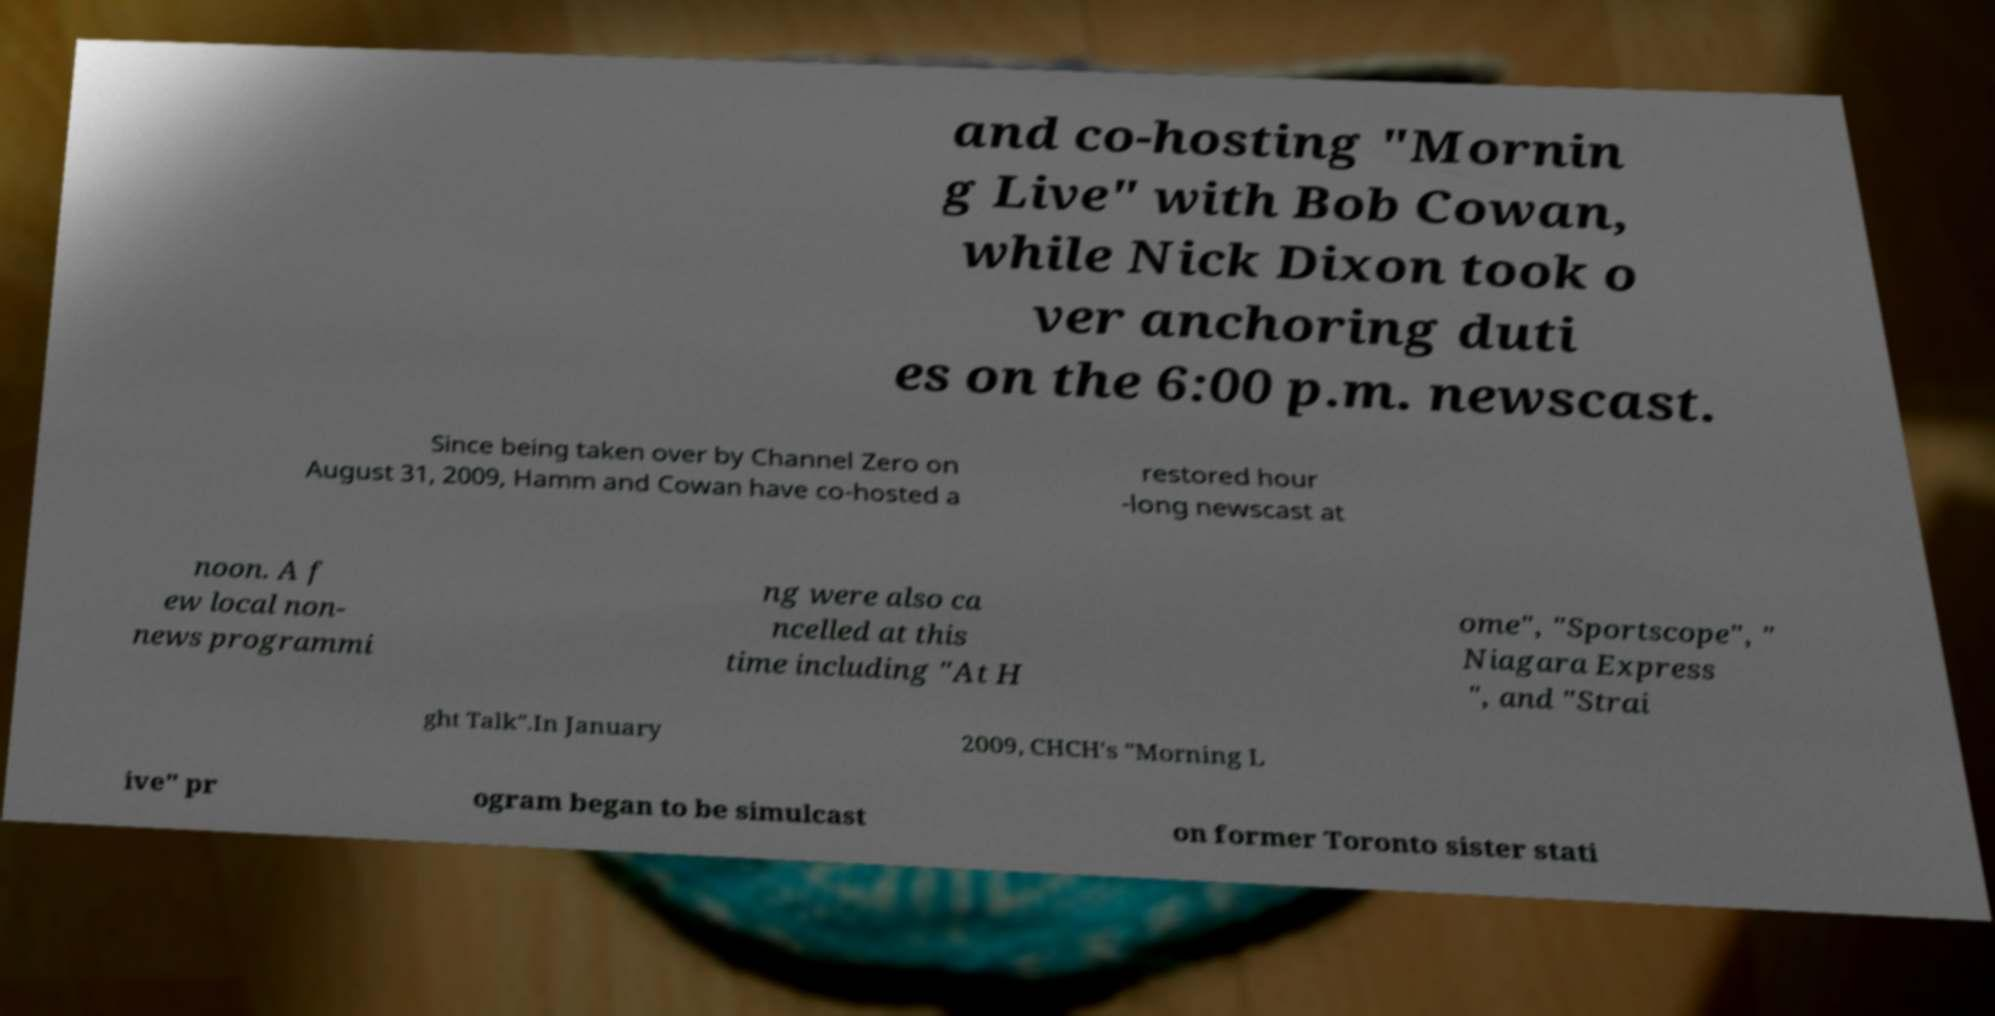Could you assist in decoding the text presented in this image and type it out clearly? and co-hosting "Mornin g Live" with Bob Cowan, while Nick Dixon took o ver anchoring duti es on the 6:00 p.m. newscast. Since being taken over by Channel Zero on August 31, 2009, Hamm and Cowan have co-hosted a restored hour -long newscast at noon. A f ew local non- news programmi ng were also ca ncelled at this time including "At H ome", "Sportscope", " Niagara Express ", and "Strai ght Talk".In January 2009, CHCH's "Morning L ive" pr ogram began to be simulcast on former Toronto sister stati 